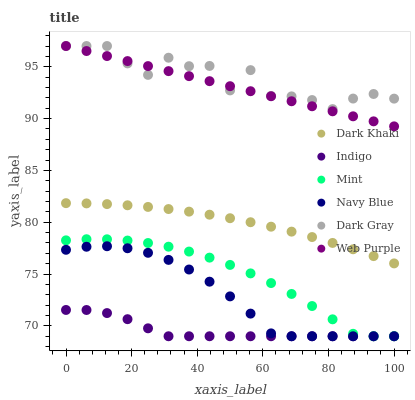Does Indigo have the minimum area under the curve?
Answer yes or no. Yes. Does Dark Gray have the maximum area under the curve?
Answer yes or no. Yes. Does Navy Blue have the minimum area under the curve?
Answer yes or no. No. Does Navy Blue have the maximum area under the curve?
Answer yes or no. No. Is Web Purple the smoothest?
Answer yes or no. Yes. Is Dark Gray the roughest?
Answer yes or no. Yes. Is Indigo the smoothest?
Answer yes or no. No. Is Indigo the roughest?
Answer yes or no. No. Does Indigo have the lowest value?
Answer yes or no. Yes. Does Dark Khaki have the lowest value?
Answer yes or no. No. Does Web Purple have the highest value?
Answer yes or no. Yes. Does Navy Blue have the highest value?
Answer yes or no. No. Is Dark Khaki less than Web Purple?
Answer yes or no. Yes. Is Web Purple greater than Dark Khaki?
Answer yes or no. Yes. Does Dark Gray intersect Web Purple?
Answer yes or no. Yes. Is Dark Gray less than Web Purple?
Answer yes or no. No. Is Dark Gray greater than Web Purple?
Answer yes or no. No. Does Dark Khaki intersect Web Purple?
Answer yes or no. No. 